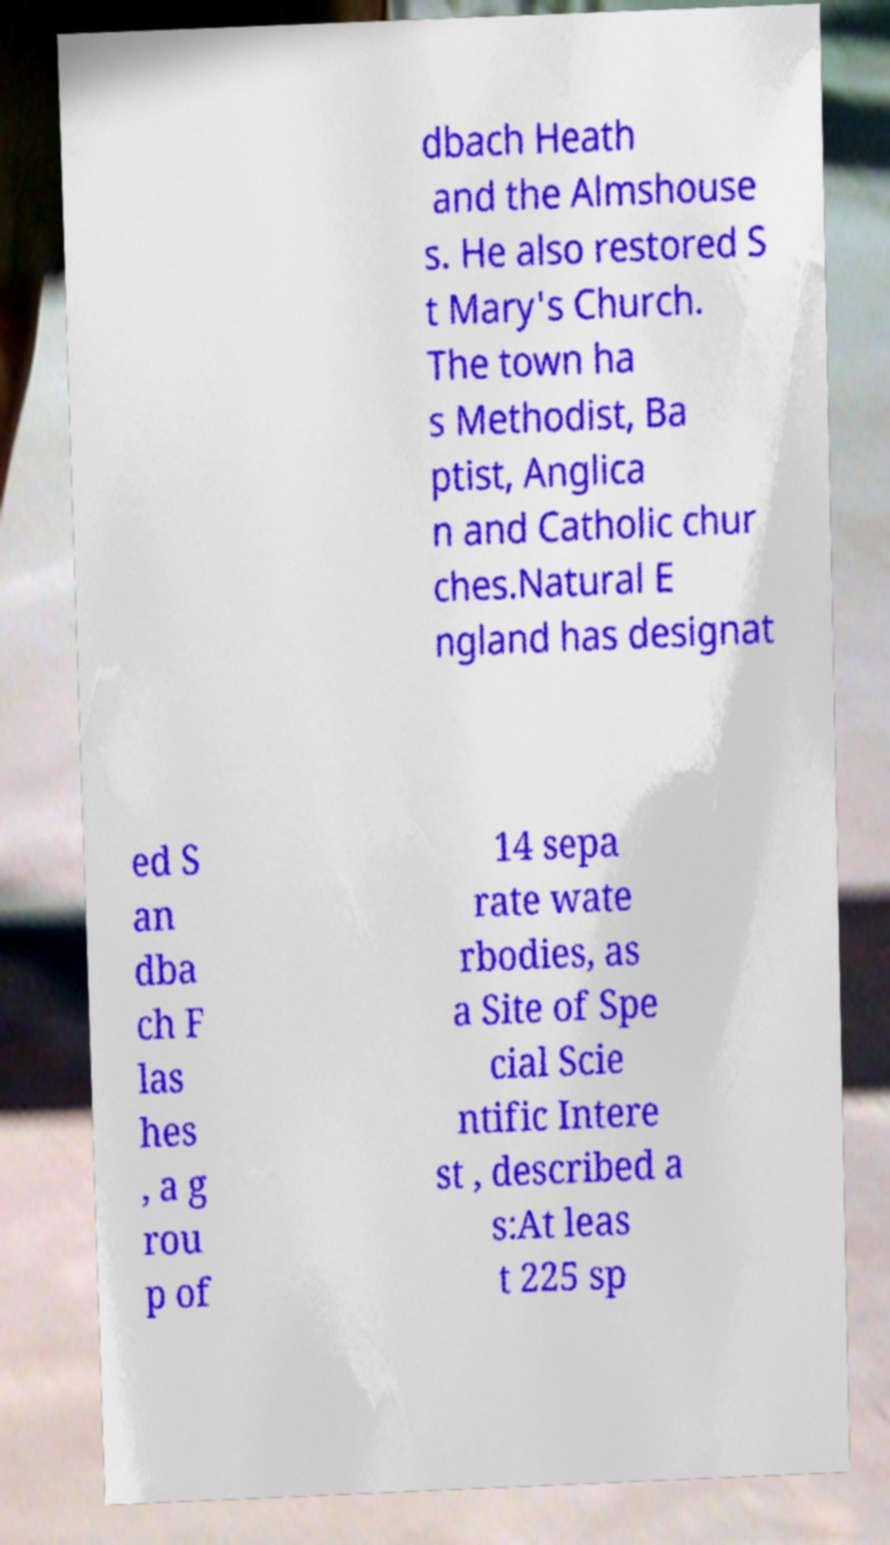For documentation purposes, I need the text within this image transcribed. Could you provide that? dbach Heath and the Almshouse s. He also restored S t Mary's Church. The town ha s Methodist, Ba ptist, Anglica n and Catholic chur ches.Natural E ngland has designat ed S an dba ch F las hes , a g rou p of 14 sepa rate wate rbodies, as a Site of Spe cial Scie ntific Intere st , described a s:At leas t 225 sp 